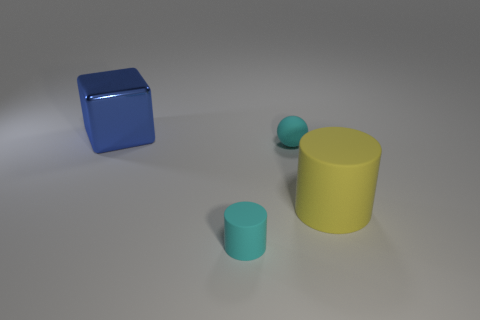What is the shape of the large yellow object that is made of the same material as the cyan cylinder?
Provide a succinct answer. Cylinder. The matte sphere has what size?
Your answer should be compact. Small. Is the blue shiny block the same size as the cyan cylinder?
Your answer should be compact. No. What number of objects are rubber objects that are behind the yellow matte cylinder or things right of the cyan rubber ball?
Keep it short and to the point. 2. What number of small cyan rubber things are in front of the cylinder behind the cyan thing that is on the left side of the ball?
Keep it short and to the point. 1. There is a metal thing behind the small cyan rubber ball; what is its size?
Ensure brevity in your answer.  Large. How many yellow rubber cylinders have the same size as the blue object?
Your answer should be compact. 1. There is a blue thing; is its size the same as the rubber cylinder that is right of the cyan ball?
Provide a succinct answer. Yes. How many objects are either tiny brown rubber balls or matte cylinders?
Your answer should be very brief. 2. How many tiny cylinders have the same color as the ball?
Provide a succinct answer. 1. 